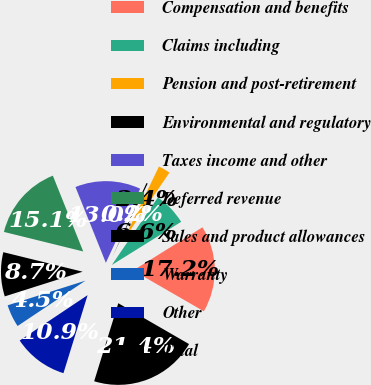Convert chart to OTSL. <chart><loc_0><loc_0><loc_500><loc_500><pie_chart><fcel>Compensation and benefits<fcel>Claims including<fcel>Pension and post-retirement<fcel>Environmental and regulatory<fcel>Taxes income and other<fcel>Deferred revenue<fcel>Sales and product allowances<fcel>Warranty<fcel>Other<fcel>Total<nl><fcel>17.2%<fcel>6.61%<fcel>2.37%<fcel>0.25%<fcel>12.97%<fcel>15.09%<fcel>8.73%<fcel>4.49%<fcel>10.85%<fcel>21.44%<nl></chart> 